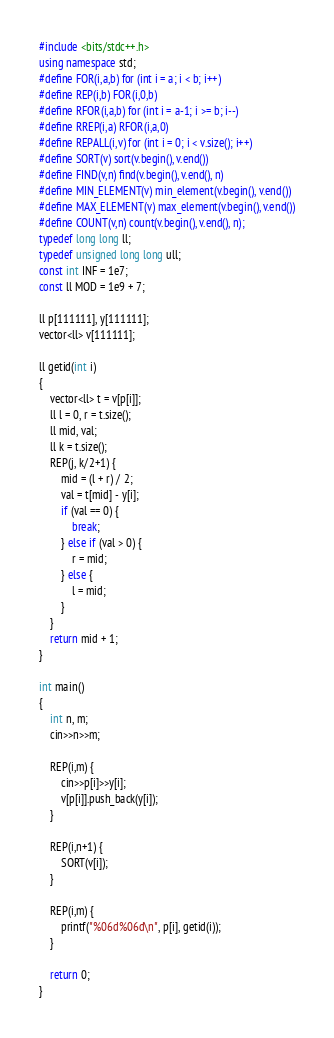Convert code to text. <code><loc_0><loc_0><loc_500><loc_500><_C++_>#include <bits/stdc++.h>
using namespace std;
#define FOR(i,a,b) for (int i = a; i < b; i++)
#define REP(i,b) FOR(i,0,b)
#define RFOR(i,a,b) for (int i = a-1; i >= b; i--)
#define RREP(i,a) RFOR(i,a,0)
#define REPALL(i,v) for (int i = 0; i < v.size(); i++)
#define SORT(v) sort(v.begin(), v.end())
#define FIND(v,n) find(v.begin(), v.end(), n)
#define MIN_ELEMENT(v) min_element(v.begin(), v.end())
#define MAX_ELEMENT(v) max_element(v.begin(), v.end())
#define COUNT(v,n) count(v.begin(), v.end(), n);
typedef long long ll;
typedef unsigned long long ull;
const int INF = 1e7;
const ll MOD = 1e9 + 7;

ll p[111111], y[111111];
vector<ll> v[111111];

ll getid(int i)
{
    vector<ll> t = v[p[i]];
    ll l = 0, r = t.size();
    ll mid, val;
    ll k = t.size();
    REP(j, k/2+1) {
        mid = (l + r) / 2;
        val = t[mid] - y[i];
        if (val == 0) {
            break;
        } else if (val > 0) {
            r = mid;
        } else {
            l = mid;
        }
    }
    return mid + 1;
}

int main()
{
    int n, m;
    cin>>n>>m;

    REP(i,m) {
        cin>>p[i]>>y[i];
        v[p[i]].push_back(y[i]);
    }

    REP(i,n+1) {
        SORT(v[i]);
    }

    REP(i,m) {
        printf("%06d%06d\n", p[i], getid(i));
    }

    return 0;
}
</code> 